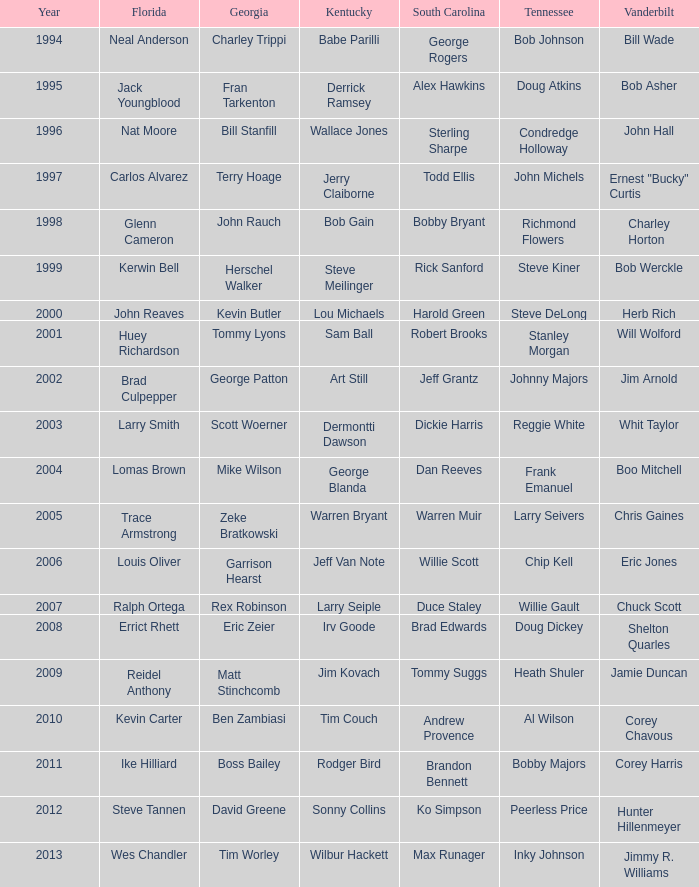What is the total Year of jeff van note ( Kentucky) 2006.0. 